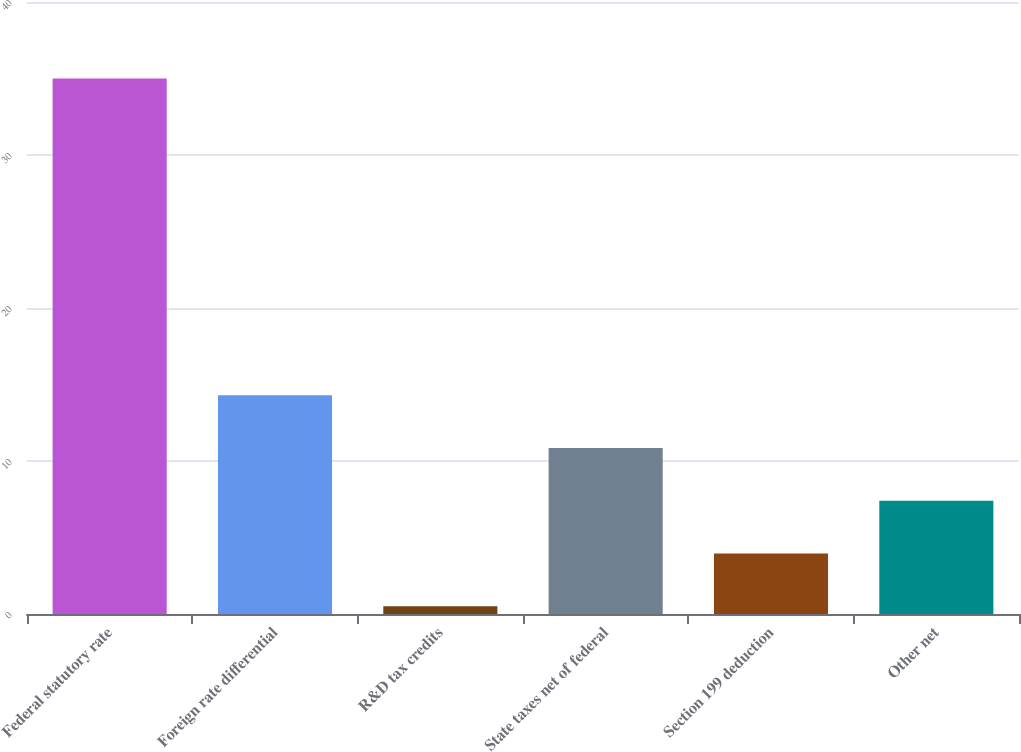<chart> <loc_0><loc_0><loc_500><loc_500><bar_chart><fcel>Federal statutory rate<fcel>Foreign rate differential<fcel>R&D tax credits<fcel>State taxes net of federal<fcel>Section 199 deduction<fcel>Other net<nl><fcel>35<fcel>14.3<fcel>0.5<fcel>10.85<fcel>3.95<fcel>7.4<nl></chart> 